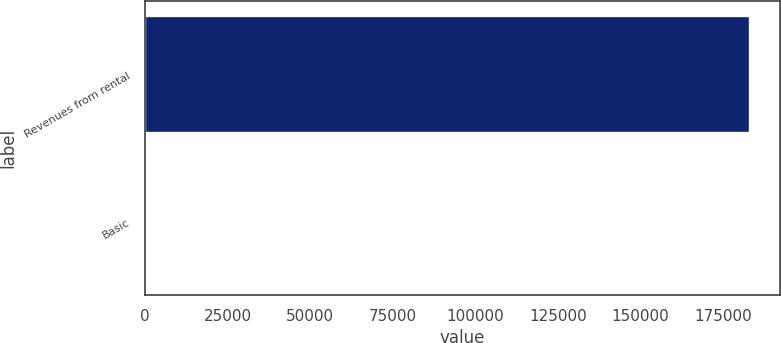Convert chart. <chart><loc_0><loc_0><loc_500><loc_500><bar_chart><fcel>Revenues from rental<fcel>Basic<nl><fcel>182970<fcel>0.33<nl></chart> 